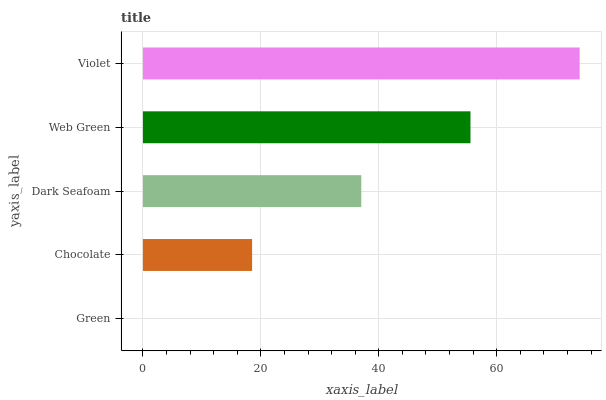Is Green the minimum?
Answer yes or no. Yes. Is Violet the maximum?
Answer yes or no. Yes. Is Chocolate the minimum?
Answer yes or no. No. Is Chocolate the maximum?
Answer yes or no. No. Is Chocolate greater than Green?
Answer yes or no. Yes. Is Green less than Chocolate?
Answer yes or no. Yes. Is Green greater than Chocolate?
Answer yes or no. No. Is Chocolate less than Green?
Answer yes or no. No. Is Dark Seafoam the high median?
Answer yes or no. Yes. Is Dark Seafoam the low median?
Answer yes or no. Yes. Is Violet the high median?
Answer yes or no. No. Is Violet the low median?
Answer yes or no. No. 